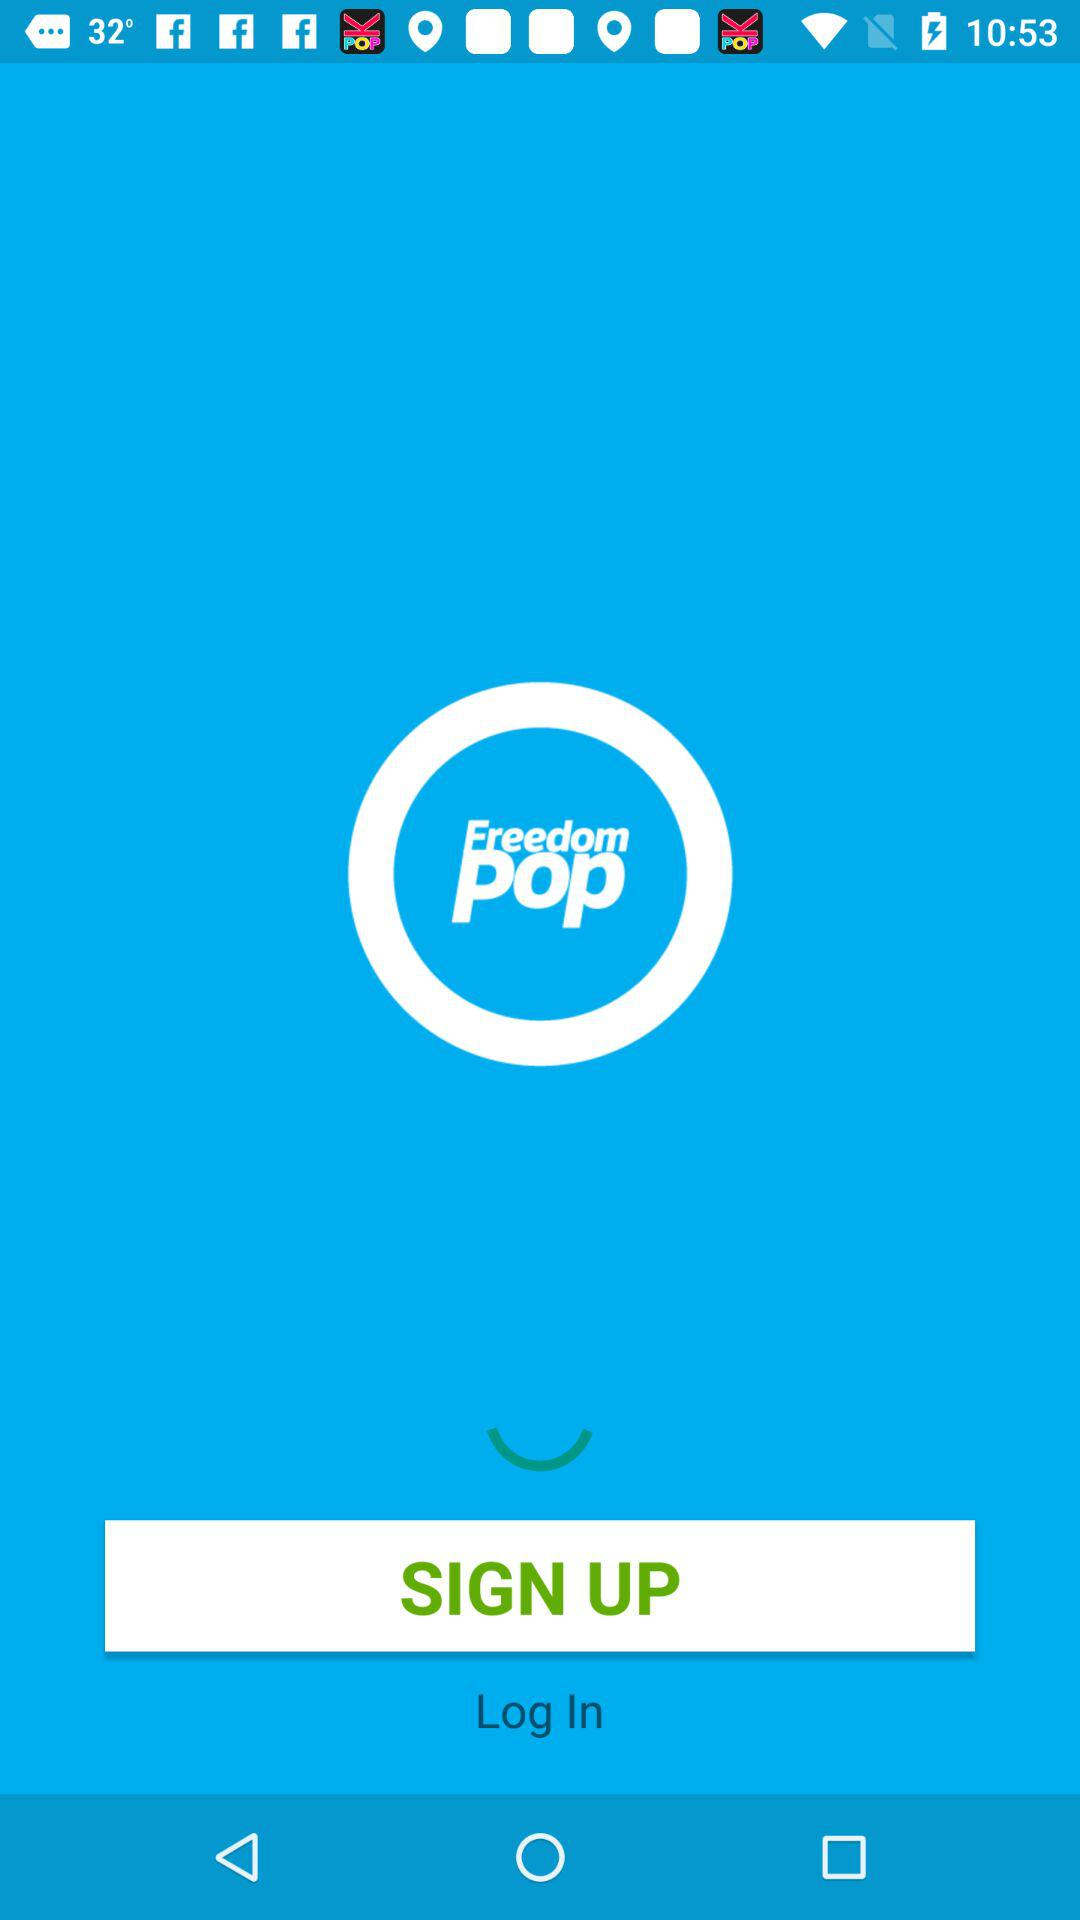What is the application name? The application name is "Freedom pop". 